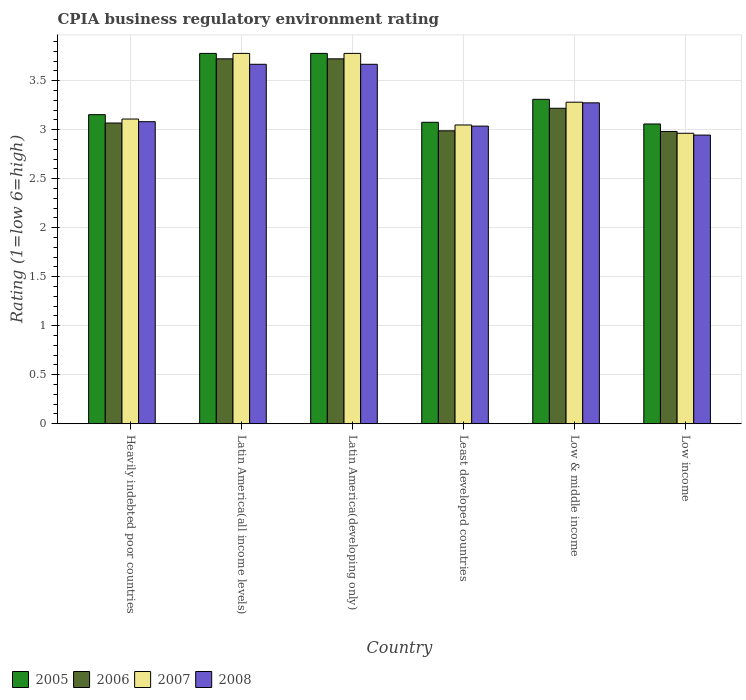How many groups of bars are there?
Keep it short and to the point. 6. Are the number of bars per tick equal to the number of legend labels?
Provide a succinct answer. Yes. What is the label of the 3rd group of bars from the left?
Give a very brief answer. Latin America(developing only). In how many cases, is the number of bars for a given country not equal to the number of legend labels?
Your answer should be very brief. 0. What is the CPIA rating in 2007 in Low & middle income?
Your response must be concise. 3.28. Across all countries, what is the maximum CPIA rating in 2008?
Offer a terse response. 3.67. Across all countries, what is the minimum CPIA rating in 2007?
Make the answer very short. 2.96. In which country was the CPIA rating in 2008 maximum?
Your answer should be very brief. Latin America(all income levels). In which country was the CPIA rating in 2008 minimum?
Provide a succinct answer. Low income. What is the total CPIA rating in 2005 in the graph?
Your response must be concise. 20.15. What is the difference between the CPIA rating in 2005 in Heavily indebted poor countries and that in Low & middle income?
Your response must be concise. -0.16. What is the difference between the CPIA rating in 2005 in Low income and the CPIA rating in 2008 in Heavily indebted poor countries?
Offer a very short reply. -0.02. What is the average CPIA rating in 2005 per country?
Provide a succinct answer. 3.36. What is the difference between the CPIA rating of/in 2005 and CPIA rating of/in 2007 in Heavily indebted poor countries?
Offer a very short reply. 0.04. In how many countries, is the CPIA rating in 2008 greater than 0.4?
Provide a short and direct response. 6. What is the ratio of the CPIA rating in 2008 in Latin America(developing only) to that in Low income?
Offer a very short reply. 1.25. What is the difference between the highest and the second highest CPIA rating in 2005?
Keep it short and to the point. -0.47. What is the difference between the highest and the lowest CPIA rating in 2006?
Provide a succinct answer. 0.74. What does the 2nd bar from the right in Least developed countries represents?
Your response must be concise. 2007. Is it the case that in every country, the sum of the CPIA rating in 2007 and CPIA rating in 2008 is greater than the CPIA rating in 2005?
Your answer should be compact. Yes. Are all the bars in the graph horizontal?
Keep it short and to the point. No. What is the difference between two consecutive major ticks on the Y-axis?
Provide a short and direct response. 0.5. Are the values on the major ticks of Y-axis written in scientific E-notation?
Ensure brevity in your answer.  No. Does the graph contain grids?
Provide a short and direct response. Yes. Where does the legend appear in the graph?
Your response must be concise. Bottom left. How are the legend labels stacked?
Give a very brief answer. Horizontal. What is the title of the graph?
Make the answer very short. CPIA business regulatory environment rating. Does "1979" appear as one of the legend labels in the graph?
Your response must be concise. No. What is the label or title of the X-axis?
Give a very brief answer. Country. What is the label or title of the Y-axis?
Your answer should be very brief. Rating (1=low 6=high). What is the Rating (1=low 6=high) of 2005 in Heavily indebted poor countries?
Provide a short and direct response. 3.15. What is the Rating (1=low 6=high) in 2006 in Heavily indebted poor countries?
Offer a terse response. 3.07. What is the Rating (1=low 6=high) of 2007 in Heavily indebted poor countries?
Your response must be concise. 3.11. What is the Rating (1=low 6=high) of 2008 in Heavily indebted poor countries?
Provide a succinct answer. 3.08. What is the Rating (1=low 6=high) of 2005 in Latin America(all income levels)?
Provide a short and direct response. 3.78. What is the Rating (1=low 6=high) of 2006 in Latin America(all income levels)?
Ensure brevity in your answer.  3.72. What is the Rating (1=low 6=high) in 2007 in Latin America(all income levels)?
Your answer should be compact. 3.78. What is the Rating (1=low 6=high) of 2008 in Latin America(all income levels)?
Give a very brief answer. 3.67. What is the Rating (1=low 6=high) of 2005 in Latin America(developing only)?
Your answer should be compact. 3.78. What is the Rating (1=low 6=high) in 2006 in Latin America(developing only)?
Ensure brevity in your answer.  3.72. What is the Rating (1=low 6=high) in 2007 in Latin America(developing only)?
Your answer should be very brief. 3.78. What is the Rating (1=low 6=high) in 2008 in Latin America(developing only)?
Ensure brevity in your answer.  3.67. What is the Rating (1=low 6=high) of 2005 in Least developed countries?
Your response must be concise. 3.08. What is the Rating (1=low 6=high) in 2006 in Least developed countries?
Offer a very short reply. 2.99. What is the Rating (1=low 6=high) in 2007 in Least developed countries?
Your response must be concise. 3.05. What is the Rating (1=low 6=high) of 2008 in Least developed countries?
Your response must be concise. 3.04. What is the Rating (1=low 6=high) of 2005 in Low & middle income?
Offer a very short reply. 3.31. What is the Rating (1=low 6=high) in 2006 in Low & middle income?
Offer a terse response. 3.22. What is the Rating (1=low 6=high) in 2007 in Low & middle income?
Provide a short and direct response. 3.28. What is the Rating (1=low 6=high) of 2008 in Low & middle income?
Your response must be concise. 3.27. What is the Rating (1=low 6=high) in 2005 in Low income?
Keep it short and to the point. 3.06. What is the Rating (1=low 6=high) of 2006 in Low income?
Your answer should be very brief. 2.98. What is the Rating (1=low 6=high) of 2007 in Low income?
Your answer should be compact. 2.96. What is the Rating (1=low 6=high) of 2008 in Low income?
Keep it short and to the point. 2.94. Across all countries, what is the maximum Rating (1=low 6=high) of 2005?
Provide a succinct answer. 3.78. Across all countries, what is the maximum Rating (1=low 6=high) in 2006?
Provide a succinct answer. 3.72. Across all countries, what is the maximum Rating (1=low 6=high) in 2007?
Offer a terse response. 3.78. Across all countries, what is the maximum Rating (1=low 6=high) of 2008?
Keep it short and to the point. 3.67. Across all countries, what is the minimum Rating (1=low 6=high) of 2005?
Make the answer very short. 3.06. Across all countries, what is the minimum Rating (1=low 6=high) in 2006?
Ensure brevity in your answer.  2.98. Across all countries, what is the minimum Rating (1=low 6=high) in 2007?
Ensure brevity in your answer.  2.96. Across all countries, what is the minimum Rating (1=low 6=high) in 2008?
Your answer should be very brief. 2.94. What is the total Rating (1=low 6=high) of 2005 in the graph?
Ensure brevity in your answer.  20.15. What is the total Rating (1=low 6=high) in 2006 in the graph?
Offer a terse response. 19.7. What is the total Rating (1=low 6=high) of 2007 in the graph?
Keep it short and to the point. 19.95. What is the total Rating (1=low 6=high) in 2008 in the graph?
Keep it short and to the point. 19.67. What is the difference between the Rating (1=low 6=high) of 2005 in Heavily indebted poor countries and that in Latin America(all income levels)?
Provide a succinct answer. -0.62. What is the difference between the Rating (1=low 6=high) of 2006 in Heavily indebted poor countries and that in Latin America(all income levels)?
Provide a succinct answer. -0.65. What is the difference between the Rating (1=low 6=high) in 2007 in Heavily indebted poor countries and that in Latin America(all income levels)?
Provide a short and direct response. -0.67. What is the difference between the Rating (1=low 6=high) of 2008 in Heavily indebted poor countries and that in Latin America(all income levels)?
Your answer should be compact. -0.59. What is the difference between the Rating (1=low 6=high) of 2005 in Heavily indebted poor countries and that in Latin America(developing only)?
Give a very brief answer. -0.62. What is the difference between the Rating (1=low 6=high) in 2006 in Heavily indebted poor countries and that in Latin America(developing only)?
Offer a very short reply. -0.65. What is the difference between the Rating (1=low 6=high) in 2007 in Heavily indebted poor countries and that in Latin America(developing only)?
Offer a very short reply. -0.67. What is the difference between the Rating (1=low 6=high) of 2008 in Heavily indebted poor countries and that in Latin America(developing only)?
Your answer should be compact. -0.59. What is the difference between the Rating (1=low 6=high) in 2005 in Heavily indebted poor countries and that in Least developed countries?
Make the answer very short. 0.08. What is the difference between the Rating (1=low 6=high) of 2006 in Heavily indebted poor countries and that in Least developed countries?
Your answer should be compact. 0.08. What is the difference between the Rating (1=low 6=high) of 2007 in Heavily indebted poor countries and that in Least developed countries?
Your response must be concise. 0.06. What is the difference between the Rating (1=low 6=high) of 2008 in Heavily indebted poor countries and that in Least developed countries?
Your answer should be very brief. 0.05. What is the difference between the Rating (1=low 6=high) in 2005 in Heavily indebted poor countries and that in Low & middle income?
Offer a very short reply. -0.16. What is the difference between the Rating (1=low 6=high) in 2006 in Heavily indebted poor countries and that in Low & middle income?
Your response must be concise. -0.15. What is the difference between the Rating (1=low 6=high) in 2007 in Heavily indebted poor countries and that in Low & middle income?
Your response must be concise. -0.17. What is the difference between the Rating (1=low 6=high) in 2008 in Heavily indebted poor countries and that in Low & middle income?
Offer a very short reply. -0.19. What is the difference between the Rating (1=low 6=high) of 2005 in Heavily indebted poor countries and that in Low income?
Ensure brevity in your answer.  0.1. What is the difference between the Rating (1=low 6=high) in 2006 in Heavily indebted poor countries and that in Low income?
Your response must be concise. 0.09. What is the difference between the Rating (1=low 6=high) in 2007 in Heavily indebted poor countries and that in Low income?
Make the answer very short. 0.15. What is the difference between the Rating (1=low 6=high) of 2008 in Heavily indebted poor countries and that in Low income?
Give a very brief answer. 0.14. What is the difference between the Rating (1=low 6=high) of 2005 in Latin America(all income levels) and that in Latin America(developing only)?
Keep it short and to the point. 0. What is the difference between the Rating (1=low 6=high) of 2006 in Latin America(all income levels) and that in Latin America(developing only)?
Offer a very short reply. 0. What is the difference between the Rating (1=low 6=high) in 2005 in Latin America(all income levels) and that in Least developed countries?
Your answer should be very brief. 0.7. What is the difference between the Rating (1=low 6=high) in 2006 in Latin America(all income levels) and that in Least developed countries?
Your response must be concise. 0.73. What is the difference between the Rating (1=low 6=high) of 2007 in Latin America(all income levels) and that in Least developed countries?
Provide a short and direct response. 0.73. What is the difference between the Rating (1=low 6=high) of 2008 in Latin America(all income levels) and that in Least developed countries?
Your response must be concise. 0.63. What is the difference between the Rating (1=low 6=high) of 2005 in Latin America(all income levels) and that in Low & middle income?
Offer a very short reply. 0.47. What is the difference between the Rating (1=low 6=high) in 2006 in Latin America(all income levels) and that in Low & middle income?
Ensure brevity in your answer.  0.5. What is the difference between the Rating (1=low 6=high) in 2007 in Latin America(all income levels) and that in Low & middle income?
Offer a very short reply. 0.5. What is the difference between the Rating (1=low 6=high) in 2008 in Latin America(all income levels) and that in Low & middle income?
Provide a short and direct response. 0.39. What is the difference between the Rating (1=low 6=high) of 2005 in Latin America(all income levels) and that in Low income?
Your answer should be compact. 0.72. What is the difference between the Rating (1=low 6=high) of 2006 in Latin America(all income levels) and that in Low income?
Keep it short and to the point. 0.74. What is the difference between the Rating (1=low 6=high) of 2007 in Latin America(all income levels) and that in Low income?
Make the answer very short. 0.81. What is the difference between the Rating (1=low 6=high) in 2008 in Latin America(all income levels) and that in Low income?
Offer a terse response. 0.72. What is the difference between the Rating (1=low 6=high) in 2005 in Latin America(developing only) and that in Least developed countries?
Offer a very short reply. 0.7. What is the difference between the Rating (1=low 6=high) of 2006 in Latin America(developing only) and that in Least developed countries?
Your response must be concise. 0.73. What is the difference between the Rating (1=low 6=high) of 2007 in Latin America(developing only) and that in Least developed countries?
Your answer should be very brief. 0.73. What is the difference between the Rating (1=low 6=high) of 2008 in Latin America(developing only) and that in Least developed countries?
Offer a very short reply. 0.63. What is the difference between the Rating (1=low 6=high) in 2005 in Latin America(developing only) and that in Low & middle income?
Make the answer very short. 0.47. What is the difference between the Rating (1=low 6=high) in 2006 in Latin America(developing only) and that in Low & middle income?
Keep it short and to the point. 0.5. What is the difference between the Rating (1=low 6=high) in 2007 in Latin America(developing only) and that in Low & middle income?
Provide a short and direct response. 0.5. What is the difference between the Rating (1=low 6=high) of 2008 in Latin America(developing only) and that in Low & middle income?
Offer a very short reply. 0.39. What is the difference between the Rating (1=low 6=high) of 2005 in Latin America(developing only) and that in Low income?
Your answer should be very brief. 0.72. What is the difference between the Rating (1=low 6=high) of 2006 in Latin America(developing only) and that in Low income?
Ensure brevity in your answer.  0.74. What is the difference between the Rating (1=low 6=high) in 2007 in Latin America(developing only) and that in Low income?
Your response must be concise. 0.81. What is the difference between the Rating (1=low 6=high) in 2008 in Latin America(developing only) and that in Low income?
Provide a succinct answer. 0.72. What is the difference between the Rating (1=low 6=high) of 2005 in Least developed countries and that in Low & middle income?
Give a very brief answer. -0.23. What is the difference between the Rating (1=low 6=high) in 2006 in Least developed countries and that in Low & middle income?
Provide a succinct answer. -0.23. What is the difference between the Rating (1=low 6=high) of 2007 in Least developed countries and that in Low & middle income?
Keep it short and to the point. -0.23. What is the difference between the Rating (1=low 6=high) in 2008 in Least developed countries and that in Low & middle income?
Ensure brevity in your answer.  -0.24. What is the difference between the Rating (1=low 6=high) in 2005 in Least developed countries and that in Low income?
Keep it short and to the point. 0.02. What is the difference between the Rating (1=low 6=high) in 2006 in Least developed countries and that in Low income?
Keep it short and to the point. 0.01. What is the difference between the Rating (1=low 6=high) of 2007 in Least developed countries and that in Low income?
Keep it short and to the point. 0.08. What is the difference between the Rating (1=low 6=high) of 2008 in Least developed countries and that in Low income?
Your answer should be very brief. 0.09. What is the difference between the Rating (1=low 6=high) in 2005 in Low & middle income and that in Low income?
Provide a short and direct response. 0.25. What is the difference between the Rating (1=low 6=high) in 2006 in Low & middle income and that in Low income?
Provide a short and direct response. 0.24. What is the difference between the Rating (1=low 6=high) in 2007 in Low & middle income and that in Low income?
Offer a very short reply. 0.32. What is the difference between the Rating (1=low 6=high) in 2008 in Low & middle income and that in Low income?
Provide a short and direct response. 0.33. What is the difference between the Rating (1=low 6=high) in 2005 in Heavily indebted poor countries and the Rating (1=low 6=high) in 2006 in Latin America(all income levels)?
Your answer should be very brief. -0.57. What is the difference between the Rating (1=low 6=high) in 2005 in Heavily indebted poor countries and the Rating (1=low 6=high) in 2007 in Latin America(all income levels)?
Your response must be concise. -0.62. What is the difference between the Rating (1=low 6=high) in 2005 in Heavily indebted poor countries and the Rating (1=low 6=high) in 2008 in Latin America(all income levels)?
Your answer should be compact. -0.51. What is the difference between the Rating (1=low 6=high) of 2006 in Heavily indebted poor countries and the Rating (1=low 6=high) of 2007 in Latin America(all income levels)?
Give a very brief answer. -0.71. What is the difference between the Rating (1=low 6=high) in 2006 in Heavily indebted poor countries and the Rating (1=low 6=high) in 2008 in Latin America(all income levels)?
Offer a very short reply. -0.6. What is the difference between the Rating (1=low 6=high) in 2007 in Heavily indebted poor countries and the Rating (1=low 6=high) in 2008 in Latin America(all income levels)?
Your answer should be compact. -0.56. What is the difference between the Rating (1=low 6=high) in 2005 in Heavily indebted poor countries and the Rating (1=low 6=high) in 2006 in Latin America(developing only)?
Your answer should be compact. -0.57. What is the difference between the Rating (1=low 6=high) of 2005 in Heavily indebted poor countries and the Rating (1=low 6=high) of 2007 in Latin America(developing only)?
Keep it short and to the point. -0.62. What is the difference between the Rating (1=low 6=high) of 2005 in Heavily indebted poor countries and the Rating (1=low 6=high) of 2008 in Latin America(developing only)?
Provide a short and direct response. -0.51. What is the difference between the Rating (1=low 6=high) of 2006 in Heavily indebted poor countries and the Rating (1=low 6=high) of 2007 in Latin America(developing only)?
Ensure brevity in your answer.  -0.71. What is the difference between the Rating (1=low 6=high) of 2006 in Heavily indebted poor countries and the Rating (1=low 6=high) of 2008 in Latin America(developing only)?
Keep it short and to the point. -0.6. What is the difference between the Rating (1=low 6=high) in 2007 in Heavily indebted poor countries and the Rating (1=low 6=high) in 2008 in Latin America(developing only)?
Ensure brevity in your answer.  -0.56. What is the difference between the Rating (1=low 6=high) of 2005 in Heavily indebted poor countries and the Rating (1=low 6=high) of 2006 in Least developed countries?
Your answer should be compact. 0.16. What is the difference between the Rating (1=low 6=high) of 2005 in Heavily indebted poor countries and the Rating (1=low 6=high) of 2007 in Least developed countries?
Your answer should be compact. 0.11. What is the difference between the Rating (1=low 6=high) in 2005 in Heavily indebted poor countries and the Rating (1=low 6=high) in 2008 in Least developed countries?
Ensure brevity in your answer.  0.12. What is the difference between the Rating (1=low 6=high) of 2006 in Heavily indebted poor countries and the Rating (1=low 6=high) of 2007 in Least developed countries?
Offer a terse response. 0.02. What is the difference between the Rating (1=low 6=high) in 2006 in Heavily indebted poor countries and the Rating (1=low 6=high) in 2008 in Least developed countries?
Your response must be concise. 0.03. What is the difference between the Rating (1=low 6=high) of 2007 in Heavily indebted poor countries and the Rating (1=low 6=high) of 2008 in Least developed countries?
Your answer should be compact. 0.07. What is the difference between the Rating (1=low 6=high) of 2005 in Heavily indebted poor countries and the Rating (1=low 6=high) of 2006 in Low & middle income?
Make the answer very short. -0.07. What is the difference between the Rating (1=low 6=high) of 2005 in Heavily indebted poor countries and the Rating (1=low 6=high) of 2007 in Low & middle income?
Your answer should be compact. -0.13. What is the difference between the Rating (1=low 6=high) in 2005 in Heavily indebted poor countries and the Rating (1=low 6=high) in 2008 in Low & middle income?
Ensure brevity in your answer.  -0.12. What is the difference between the Rating (1=low 6=high) in 2006 in Heavily indebted poor countries and the Rating (1=low 6=high) in 2007 in Low & middle income?
Keep it short and to the point. -0.21. What is the difference between the Rating (1=low 6=high) in 2006 in Heavily indebted poor countries and the Rating (1=low 6=high) in 2008 in Low & middle income?
Keep it short and to the point. -0.21. What is the difference between the Rating (1=low 6=high) of 2007 in Heavily indebted poor countries and the Rating (1=low 6=high) of 2008 in Low & middle income?
Give a very brief answer. -0.17. What is the difference between the Rating (1=low 6=high) of 2005 in Heavily indebted poor countries and the Rating (1=low 6=high) of 2006 in Low income?
Offer a terse response. 0.17. What is the difference between the Rating (1=low 6=high) of 2005 in Heavily indebted poor countries and the Rating (1=low 6=high) of 2007 in Low income?
Keep it short and to the point. 0.19. What is the difference between the Rating (1=low 6=high) in 2005 in Heavily indebted poor countries and the Rating (1=low 6=high) in 2008 in Low income?
Your answer should be very brief. 0.21. What is the difference between the Rating (1=low 6=high) of 2006 in Heavily indebted poor countries and the Rating (1=low 6=high) of 2007 in Low income?
Offer a terse response. 0.1. What is the difference between the Rating (1=low 6=high) of 2006 in Heavily indebted poor countries and the Rating (1=low 6=high) of 2008 in Low income?
Your response must be concise. 0.12. What is the difference between the Rating (1=low 6=high) of 2007 in Heavily indebted poor countries and the Rating (1=low 6=high) of 2008 in Low income?
Ensure brevity in your answer.  0.16. What is the difference between the Rating (1=low 6=high) in 2005 in Latin America(all income levels) and the Rating (1=low 6=high) in 2006 in Latin America(developing only)?
Your response must be concise. 0.06. What is the difference between the Rating (1=low 6=high) in 2005 in Latin America(all income levels) and the Rating (1=low 6=high) in 2008 in Latin America(developing only)?
Your answer should be compact. 0.11. What is the difference between the Rating (1=low 6=high) in 2006 in Latin America(all income levels) and the Rating (1=low 6=high) in 2007 in Latin America(developing only)?
Provide a succinct answer. -0.06. What is the difference between the Rating (1=low 6=high) in 2006 in Latin America(all income levels) and the Rating (1=low 6=high) in 2008 in Latin America(developing only)?
Give a very brief answer. 0.06. What is the difference between the Rating (1=low 6=high) of 2007 in Latin America(all income levels) and the Rating (1=low 6=high) of 2008 in Latin America(developing only)?
Provide a short and direct response. 0.11. What is the difference between the Rating (1=low 6=high) in 2005 in Latin America(all income levels) and the Rating (1=low 6=high) in 2006 in Least developed countries?
Offer a terse response. 0.79. What is the difference between the Rating (1=low 6=high) of 2005 in Latin America(all income levels) and the Rating (1=low 6=high) of 2007 in Least developed countries?
Your response must be concise. 0.73. What is the difference between the Rating (1=low 6=high) in 2005 in Latin America(all income levels) and the Rating (1=low 6=high) in 2008 in Least developed countries?
Provide a succinct answer. 0.74. What is the difference between the Rating (1=low 6=high) of 2006 in Latin America(all income levels) and the Rating (1=low 6=high) of 2007 in Least developed countries?
Your response must be concise. 0.67. What is the difference between the Rating (1=low 6=high) in 2006 in Latin America(all income levels) and the Rating (1=low 6=high) in 2008 in Least developed countries?
Give a very brief answer. 0.69. What is the difference between the Rating (1=low 6=high) of 2007 in Latin America(all income levels) and the Rating (1=low 6=high) of 2008 in Least developed countries?
Provide a short and direct response. 0.74. What is the difference between the Rating (1=low 6=high) in 2005 in Latin America(all income levels) and the Rating (1=low 6=high) in 2006 in Low & middle income?
Offer a very short reply. 0.56. What is the difference between the Rating (1=low 6=high) of 2005 in Latin America(all income levels) and the Rating (1=low 6=high) of 2007 in Low & middle income?
Keep it short and to the point. 0.5. What is the difference between the Rating (1=low 6=high) in 2005 in Latin America(all income levels) and the Rating (1=low 6=high) in 2008 in Low & middle income?
Give a very brief answer. 0.5. What is the difference between the Rating (1=low 6=high) in 2006 in Latin America(all income levels) and the Rating (1=low 6=high) in 2007 in Low & middle income?
Give a very brief answer. 0.44. What is the difference between the Rating (1=low 6=high) in 2006 in Latin America(all income levels) and the Rating (1=low 6=high) in 2008 in Low & middle income?
Provide a short and direct response. 0.45. What is the difference between the Rating (1=low 6=high) of 2007 in Latin America(all income levels) and the Rating (1=low 6=high) of 2008 in Low & middle income?
Your answer should be very brief. 0.5. What is the difference between the Rating (1=low 6=high) in 2005 in Latin America(all income levels) and the Rating (1=low 6=high) in 2006 in Low income?
Give a very brief answer. 0.8. What is the difference between the Rating (1=low 6=high) of 2005 in Latin America(all income levels) and the Rating (1=low 6=high) of 2007 in Low income?
Provide a short and direct response. 0.81. What is the difference between the Rating (1=low 6=high) in 2005 in Latin America(all income levels) and the Rating (1=low 6=high) in 2008 in Low income?
Give a very brief answer. 0.83. What is the difference between the Rating (1=low 6=high) in 2006 in Latin America(all income levels) and the Rating (1=low 6=high) in 2007 in Low income?
Provide a short and direct response. 0.76. What is the difference between the Rating (1=low 6=high) of 2005 in Latin America(developing only) and the Rating (1=low 6=high) of 2006 in Least developed countries?
Provide a succinct answer. 0.79. What is the difference between the Rating (1=low 6=high) of 2005 in Latin America(developing only) and the Rating (1=low 6=high) of 2007 in Least developed countries?
Keep it short and to the point. 0.73. What is the difference between the Rating (1=low 6=high) in 2005 in Latin America(developing only) and the Rating (1=low 6=high) in 2008 in Least developed countries?
Give a very brief answer. 0.74. What is the difference between the Rating (1=low 6=high) of 2006 in Latin America(developing only) and the Rating (1=low 6=high) of 2007 in Least developed countries?
Offer a terse response. 0.67. What is the difference between the Rating (1=low 6=high) in 2006 in Latin America(developing only) and the Rating (1=low 6=high) in 2008 in Least developed countries?
Give a very brief answer. 0.69. What is the difference between the Rating (1=low 6=high) in 2007 in Latin America(developing only) and the Rating (1=low 6=high) in 2008 in Least developed countries?
Provide a succinct answer. 0.74. What is the difference between the Rating (1=low 6=high) of 2005 in Latin America(developing only) and the Rating (1=low 6=high) of 2006 in Low & middle income?
Offer a terse response. 0.56. What is the difference between the Rating (1=low 6=high) in 2005 in Latin America(developing only) and the Rating (1=low 6=high) in 2007 in Low & middle income?
Provide a succinct answer. 0.5. What is the difference between the Rating (1=low 6=high) of 2005 in Latin America(developing only) and the Rating (1=low 6=high) of 2008 in Low & middle income?
Provide a short and direct response. 0.5. What is the difference between the Rating (1=low 6=high) of 2006 in Latin America(developing only) and the Rating (1=low 6=high) of 2007 in Low & middle income?
Your answer should be very brief. 0.44. What is the difference between the Rating (1=low 6=high) of 2006 in Latin America(developing only) and the Rating (1=low 6=high) of 2008 in Low & middle income?
Provide a succinct answer. 0.45. What is the difference between the Rating (1=low 6=high) of 2007 in Latin America(developing only) and the Rating (1=low 6=high) of 2008 in Low & middle income?
Keep it short and to the point. 0.5. What is the difference between the Rating (1=low 6=high) of 2005 in Latin America(developing only) and the Rating (1=low 6=high) of 2006 in Low income?
Give a very brief answer. 0.8. What is the difference between the Rating (1=low 6=high) in 2005 in Latin America(developing only) and the Rating (1=low 6=high) in 2007 in Low income?
Offer a terse response. 0.81. What is the difference between the Rating (1=low 6=high) in 2006 in Latin America(developing only) and the Rating (1=low 6=high) in 2007 in Low income?
Offer a terse response. 0.76. What is the difference between the Rating (1=low 6=high) of 2005 in Least developed countries and the Rating (1=low 6=high) of 2006 in Low & middle income?
Offer a very short reply. -0.14. What is the difference between the Rating (1=low 6=high) in 2005 in Least developed countries and the Rating (1=low 6=high) in 2007 in Low & middle income?
Keep it short and to the point. -0.2. What is the difference between the Rating (1=low 6=high) in 2005 in Least developed countries and the Rating (1=low 6=high) in 2008 in Low & middle income?
Offer a terse response. -0.2. What is the difference between the Rating (1=low 6=high) of 2006 in Least developed countries and the Rating (1=low 6=high) of 2007 in Low & middle income?
Give a very brief answer. -0.29. What is the difference between the Rating (1=low 6=high) in 2006 in Least developed countries and the Rating (1=low 6=high) in 2008 in Low & middle income?
Provide a short and direct response. -0.29. What is the difference between the Rating (1=low 6=high) of 2007 in Least developed countries and the Rating (1=low 6=high) of 2008 in Low & middle income?
Give a very brief answer. -0.23. What is the difference between the Rating (1=low 6=high) in 2005 in Least developed countries and the Rating (1=low 6=high) in 2006 in Low income?
Make the answer very short. 0.09. What is the difference between the Rating (1=low 6=high) in 2005 in Least developed countries and the Rating (1=low 6=high) in 2007 in Low income?
Your answer should be very brief. 0.11. What is the difference between the Rating (1=low 6=high) of 2005 in Least developed countries and the Rating (1=low 6=high) of 2008 in Low income?
Your response must be concise. 0.13. What is the difference between the Rating (1=low 6=high) in 2006 in Least developed countries and the Rating (1=low 6=high) in 2007 in Low income?
Give a very brief answer. 0.03. What is the difference between the Rating (1=low 6=high) in 2006 in Least developed countries and the Rating (1=low 6=high) in 2008 in Low income?
Make the answer very short. 0.04. What is the difference between the Rating (1=low 6=high) in 2007 in Least developed countries and the Rating (1=low 6=high) in 2008 in Low income?
Provide a short and direct response. 0.1. What is the difference between the Rating (1=low 6=high) of 2005 in Low & middle income and the Rating (1=low 6=high) of 2006 in Low income?
Your response must be concise. 0.33. What is the difference between the Rating (1=low 6=high) in 2005 in Low & middle income and the Rating (1=low 6=high) in 2007 in Low income?
Ensure brevity in your answer.  0.35. What is the difference between the Rating (1=low 6=high) of 2005 in Low & middle income and the Rating (1=low 6=high) of 2008 in Low income?
Provide a short and direct response. 0.36. What is the difference between the Rating (1=low 6=high) in 2006 in Low & middle income and the Rating (1=low 6=high) in 2007 in Low income?
Provide a short and direct response. 0.26. What is the difference between the Rating (1=low 6=high) of 2006 in Low & middle income and the Rating (1=low 6=high) of 2008 in Low income?
Your answer should be very brief. 0.27. What is the difference between the Rating (1=low 6=high) of 2007 in Low & middle income and the Rating (1=low 6=high) of 2008 in Low income?
Give a very brief answer. 0.34. What is the average Rating (1=low 6=high) of 2005 per country?
Your answer should be very brief. 3.36. What is the average Rating (1=low 6=high) in 2006 per country?
Provide a succinct answer. 3.28. What is the average Rating (1=low 6=high) in 2007 per country?
Offer a very short reply. 3.33. What is the average Rating (1=low 6=high) of 2008 per country?
Provide a succinct answer. 3.28. What is the difference between the Rating (1=low 6=high) in 2005 and Rating (1=low 6=high) in 2006 in Heavily indebted poor countries?
Ensure brevity in your answer.  0.09. What is the difference between the Rating (1=low 6=high) of 2005 and Rating (1=low 6=high) of 2007 in Heavily indebted poor countries?
Provide a short and direct response. 0.04. What is the difference between the Rating (1=low 6=high) in 2005 and Rating (1=low 6=high) in 2008 in Heavily indebted poor countries?
Offer a very short reply. 0.07. What is the difference between the Rating (1=low 6=high) of 2006 and Rating (1=low 6=high) of 2007 in Heavily indebted poor countries?
Keep it short and to the point. -0.04. What is the difference between the Rating (1=low 6=high) in 2006 and Rating (1=low 6=high) in 2008 in Heavily indebted poor countries?
Offer a terse response. -0.01. What is the difference between the Rating (1=low 6=high) in 2007 and Rating (1=low 6=high) in 2008 in Heavily indebted poor countries?
Your answer should be very brief. 0.03. What is the difference between the Rating (1=low 6=high) in 2005 and Rating (1=low 6=high) in 2006 in Latin America(all income levels)?
Ensure brevity in your answer.  0.06. What is the difference between the Rating (1=low 6=high) of 2006 and Rating (1=low 6=high) of 2007 in Latin America(all income levels)?
Your response must be concise. -0.06. What is the difference between the Rating (1=low 6=high) of 2006 and Rating (1=low 6=high) of 2008 in Latin America(all income levels)?
Provide a short and direct response. 0.06. What is the difference between the Rating (1=low 6=high) in 2005 and Rating (1=low 6=high) in 2006 in Latin America(developing only)?
Ensure brevity in your answer.  0.06. What is the difference between the Rating (1=low 6=high) of 2006 and Rating (1=low 6=high) of 2007 in Latin America(developing only)?
Keep it short and to the point. -0.06. What is the difference between the Rating (1=low 6=high) of 2006 and Rating (1=low 6=high) of 2008 in Latin America(developing only)?
Give a very brief answer. 0.06. What is the difference between the Rating (1=low 6=high) of 2005 and Rating (1=low 6=high) of 2006 in Least developed countries?
Ensure brevity in your answer.  0.09. What is the difference between the Rating (1=low 6=high) in 2005 and Rating (1=low 6=high) in 2007 in Least developed countries?
Your response must be concise. 0.03. What is the difference between the Rating (1=low 6=high) in 2005 and Rating (1=low 6=high) in 2008 in Least developed countries?
Offer a terse response. 0.04. What is the difference between the Rating (1=low 6=high) of 2006 and Rating (1=low 6=high) of 2007 in Least developed countries?
Give a very brief answer. -0.06. What is the difference between the Rating (1=low 6=high) in 2006 and Rating (1=low 6=high) in 2008 in Least developed countries?
Give a very brief answer. -0.05. What is the difference between the Rating (1=low 6=high) of 2007 and Rating (1=low 6=high) of 2008 in Least developed countries?
Ensure brevity in your answer.  0.01. What is the difference between the Rating (1=low 6=high) of 2005 and Rating (1=low 6=high) of 2006 in Low & middle income?
Offer a very short reply. 0.09. What is the difference between the Rating (1=low 6=high) in 2005 and Rating (1=low 6=high) in 2007 in Low & middle income?
Offer a terse response. 0.03. What is the difference between the Rating (1=low 6=high) in 2005 and Rating (1=low 6=high) in 2008 in Low & middle income?
Provide a short and direct response. 0.04. What is the difference between the Rating (1=low 6=high) of 2006 and Rating (1=low 6=high) of 2007 in Low & middle income?
Give a very brief answer. -0.06. What is the difference between the Rating (1=low 6=high) in 2006 and Rating (1=low 6=high) in 2008 in Low & middle income?
Your response must be concise. -0.06. What is the difference between the Rating (1=low 6=high) of 2007 and Rating (1=low 6=high) of 2008 in Low & middle income?
Make the answer very short. 0.01. What is the difference between the Rating (1=low 6=high) of 2005 and Rating (1=low 6=high) of 2006 in Low income?
Provide a short and direct response. 0.08. What is the difference between the Rating (1=low 6=high) of 2005 and Rating (1=low 6=high) of 2007 in Low income?
Your answer should be very brief. 0.09. What is the difference between the Rating (1=low 6=high) of 2005 and Rating (1=low 6=high) of 2008 in Low income?
Give a very brief answer. 0.11. What is the difference between the Rating (1=low 6=high) in 2006 and Rating (1=low 6=high) in 2007 in Low income?
Offer a terse response. 0.02. What is the difference between the Rating (1=low 6=high) in 2006 and Rating (1=low 6=high) in 2008 in Low income?
Give a very brief answer. 0.04. What is the difference between the Rating (1=low 6=high) of 2007 and Rating (1=low 6=high) of 2008 in Low income?
Give a very brief answer. 0.02. What is the ratio of the Rating (1=low 6=high) in 2005 in Heavily indebted poor countries to that in Latin America(all income levels)?
Offer a very short reply. 0.83. What is the ratio of the Rating (1=low 6=high) of 2006 in Heavily indebted poor countries to that in Latin America(all income levels)?
Give a very brief answer. 0.82. What is the ratio of the Rating (1=low 6=high) of 2007 in Heavily indebted poor countries to that in Latin America(all income levels)?
Offer a terse response. 0.82. What is the ratio of the Rating (1=low 6=high) of 2008 in Heavily indebted poor countries to that in Latin America(all income levels)?
Ensure brevity in your answer.  0.84. What is the ratio of the Rating (1=low 6=high) in 2005 in Heavily indebted poor countries to that in Latin America(developing only)?
Make the answer very short. 0.83. What is the ratio of the Rating (1=low 6=high) of 2006 in Heavily indebted poor countries to that in Latin America(developing only)?
Your response must be concise. 0.82. What is the ratio of the Rating (1=low 6=high) in 2007 in Heavily indebted poor countries to that in Latin America(developing only)?
Your response must be concise. 0.82. What is the ratio of the Rating (1=low 6=high) in 2008 in Heavily indebted poor countries to that in Latin America(developing only)?
Your answer should be compact. 0.84. What is the ratio of the Rating (1=low 6=high) in 2005 in Heavily indebted poor countries to that in Least developed countries?
Keep it short and to the point. 1.03. What is the ratio of the Rating (1=low 6=high) of 2006 in Heavily indebted poor countries to that in Least developed countries?
Your answer should be compact. 1.03. What is the ratio of the Rating (1=low 6=high) of 2007 in Heavily indebted poor countries to that in Least developed countries?
Keep it short and to the point. 1.02. What is the ratio of the Rating (1=low 6=high) of 2008 in Heavily indebted poor countries to that in Least developed countries?
Keep it short and to the point. 1.01. What is the ratio of the Rating (1=low 6=high) in 2005 in Heavily indebted poor countries to that in Low & middle income?
Give a very brief answer. 0.95. What is the ratio of the Rating (1=low 6=high) of 2006 in Heavily indebted poor countries to that in Low & middle income?
Your answer should be very brief. 0.95. What is the ratio of the Rating (1=low 6=high) in 2007 in Heavily indebted poor countries to that in Low & middle income?
Your answer should be compact. 0.95. What is the ratio of the Rating (1=low 6=high) of 2008 in Heavily indebted poor countries to that in Low & middle income?
Your answer should be very brief. 0.94. What is the ratio of the Rating (1=low 6=high) of 2005 in Heavily indebted poor countries to that in Low income?
Make the answer very short. 1.03. What is the ratio of the Rating (1=low 6=high) of 2006 in Heavily indebted poor countries to that in Low income?
Offer a very short reply. 1.03. What is the ratio of the Rating (1=low 6=high) of 2007 in Heavily indebted poor countries to that in Low income?
Offer a very short reply. 1.05. What is the ratio of the Rating (1=low 6=high) of 2008 in Heavily indebted poor countries to that in Low income?
Provide a succinct answer. 1.05. What is the ratio of the Rating (1=low 6=high) in 2006 in Latin America(all income levels) to that in Latin America(developing only)?
Keep it short and to the point. 1. What is the ratio of the Rating (1=low 6=high) of 2005 in Latin America(all income levels) to that in Least developed countries?
Keep it short and to the point. 1.23. What is the ratio of the Rating (1=low 6=high) of 2006 in Latin America(all income levels) to that in Least developed countries?
Your response must be concise. 1.25. What is the ratio of the Rating (1=low 6=high) in 2007 in Latin America(all income levels) to that in Least developed countries?
Provide a succinct answer. 1.24. What is the ratio of the Rating (1=low 6=high) of 2008 in Latin America(all income levels) to that in Least developed countries?
Your answer should be very brief. 1.21. What is the ratio of the Rating (1=low 6=high) in 2005 in Latin America(all income levels) to that in Low & middle income?
Your answer should be very brief. 1.14. What is the ratio of the Rating (1=low 6=high) of 2006 in Latin America(all income levels) to that in Low & middle income?
Your response must be concise. 1.16. What is the ratio of the Rating (1=low 6=high) of 2007 in Latin America(all income levels) to that in Low & middle income?
Your answer should be very brief. 1.15. What is the ratio of the Rating (1=low 6=high) of 2008 in Latin America(all income levels) to that in Low & middle income?
Offer a very short reply. 1.12. What is the ratio of the Rating (1=low 6=high) in 2005 in Latin America(all income levels) to that in Low income?
Your response must be concise. 1.24. What is the ratio of the Rating (1=low 6=high) of 2006 in Latin America(all income levels) to that in Low income?
Ensure brevity in your answer.  1.25. What is the ratio of the Rating (1=low 6=high) of 2007 in Latin America(all income levels) to that in Low income?
Your response must be concise. 1.27. What is the ratio of the Rating (1=low 6=high) in 2008 in Latin America(all income levels) to that in Low income?
Give a very brief answer. 1.25. What is the ratio of the Rating (1=low 6=high) in 2005 in Latin America(developing only) to that in Least developed countries?
Offer a very short reply. 1.23. What is the ratio of the Rating (1=low 6=high) of 2006 in Latin America(developing only) to that in Least developed countries?
Provide a short and direct response. 1.25. What is the ratio of the Rating (1=low 6=high) in 2007 in Latin America(developing only) to that in Least developed countries?
Your answer should be very brief. 1.24. What is the ratio of the Rating (1=low 6=high) in 2008 in Latin America(developing only) to that in Least developed countries?
Your response must be concise. 1.21. What is the ratio of the Rating (1=low 6=high) of 2005 in Latin America(developing only) to that in Low & middle income?
Offer a terse response. 1.14. What is the ratio of the Rating (1=low 6=high) of 2006 in Latin America(developing only) to that in Low & middle income?
Your answer should be compact. 1.16. What is the ratio of the Rating (1=low 6=high) of 2007 in Latin America(developing only) to that in Low & middle income?
Give a very brief answer. 1.15. What is the ratio of the Rating (1=low 6=high) in 2008 in Latin America(developing only) to that in Low & middle income?
Give a very brief answer. 1.12. What is the ratio of the Rating (1=low 6=high) in 2005 in Latin America(developing only) to that in Low income?
Give a very brief answer. 1.24. What is the ratio of the Rating (1=low 6=high) of 2006 in Latin America(developing only) to that in Low income?
Offer a terse response. 1.25. What is the ratio of the Rating (1=low 6=high) of 2007 in Latin America(developing only) to that in Low income?
Provide a succinct answer. 1.27. What is the ratio of the Rating (1=low 6=high) in 2008 in Latin America(developing only) to that in Low income?
Keep it short and to the point. 1.25. What is the ratio of the Rating (1=low 6=high) of 2005 in Least developed countries to that in Low & middle income?
Offer a terse response. 0.93. What is the ratio of the Rating (1=low 6=high) in 2006 in Least developed countries to that in Low & middle income?
Offer a terse response. 0.93. What is the ratio of the Rating (1=low 6=high) in 2007 in Least developed countries to that in Low & middle income?
Give a very brief answer. 0.93. What is the ratio of the Rating (1=low 6=high) of 2008 in Least developed countries to that in Low & middle income?
Your answer should be compact. 0.93. What is the ratio of the Rating (1=low 6=high) of 2007 in Least developed countries to that in Low income?
Give a very brief answer. 1.03. What is the ratio of the Rating (1=low 6=high) in 2008 in Least developed countries to that in Low income?
Keep it short and to the point. 1.03. What is the ratio of the Rating (1=low 6=high) in 2005 in Low & middle income to that in Low income?
Your response must be concise. 1.08. What is the ratio of the Rating (1=low 6=high) in 2006 in Low & middle income to that in Low income?
Give a very brief answer. 1.08. What is the ratio of the Rating (1=low 6=high) of 2007 in Low & middle income to that in Low income?
Offer a terse response. 1.11. What is the ratio of the Rating (1=low 6=high) in 2008 in Low & middle income to that in Low income?
Give a very brief answer. 1.11. What is the difference between the highest and the second highest Rating (1=low 6=high) in 2005?
Make the answer very short. 0. What is the difference between the highest and the second highest Rating (1=low 6=high) of 2007?
Give a very brief answer. 0. What is the difference between the highest and the second highest Rating (1=low 6=high) of 2008?
Offer a very short reply. 0. What is the difference between the highest and the lowest Rating (1=low 6=high) of 2005?
Your answer should be very brief. 0.72. What is the difference between the highest and the lowest Rating (1=low 6=high) in 2006?
Your answer should be very brief. 0.74. What is the difference between the highest and the lowest Rating (1=low 6=high) of 2007?
Provide a short and direct response. 0.81. What is the difference between the highest and the lowest Rating (1=low 6=high) of 2008?
Give a very brief answer. 0.72. 